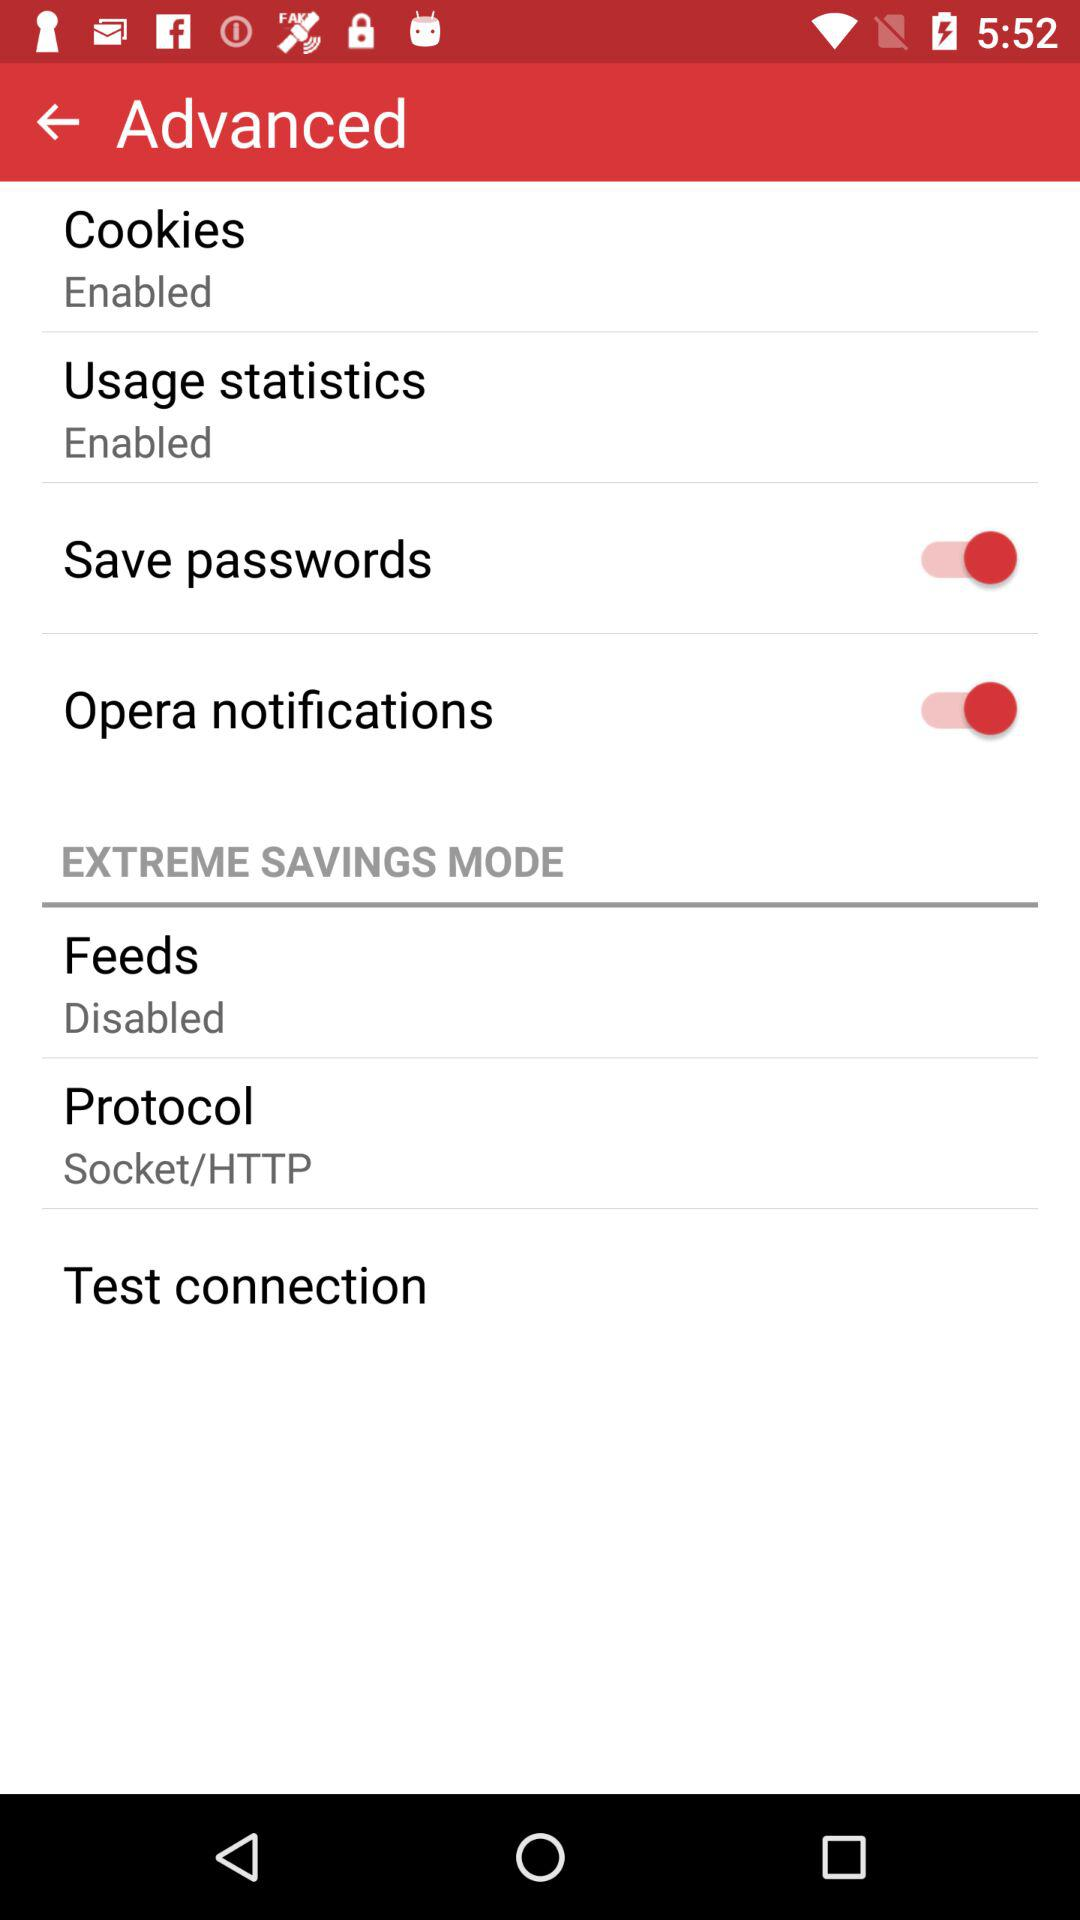Which connection will be tested?
When the provided information is insufficient, respond with <no answer>. <no answer> 